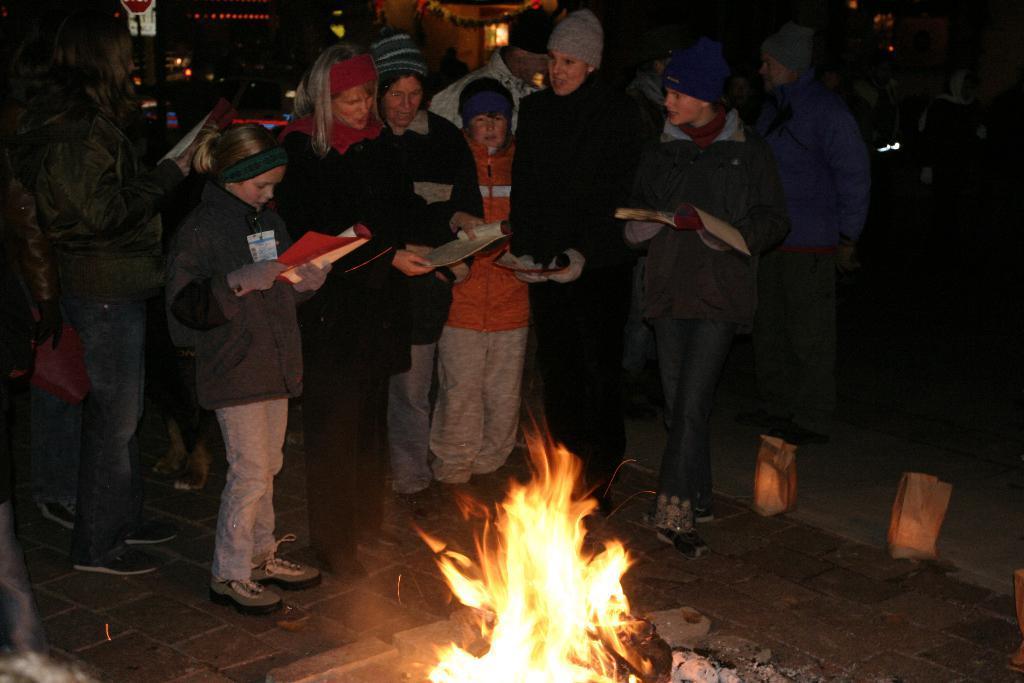In one or two sentences, can you explain what this image depicts? In this image we can see people holding books and standing on the ground. At the bottom we can see the fire. 